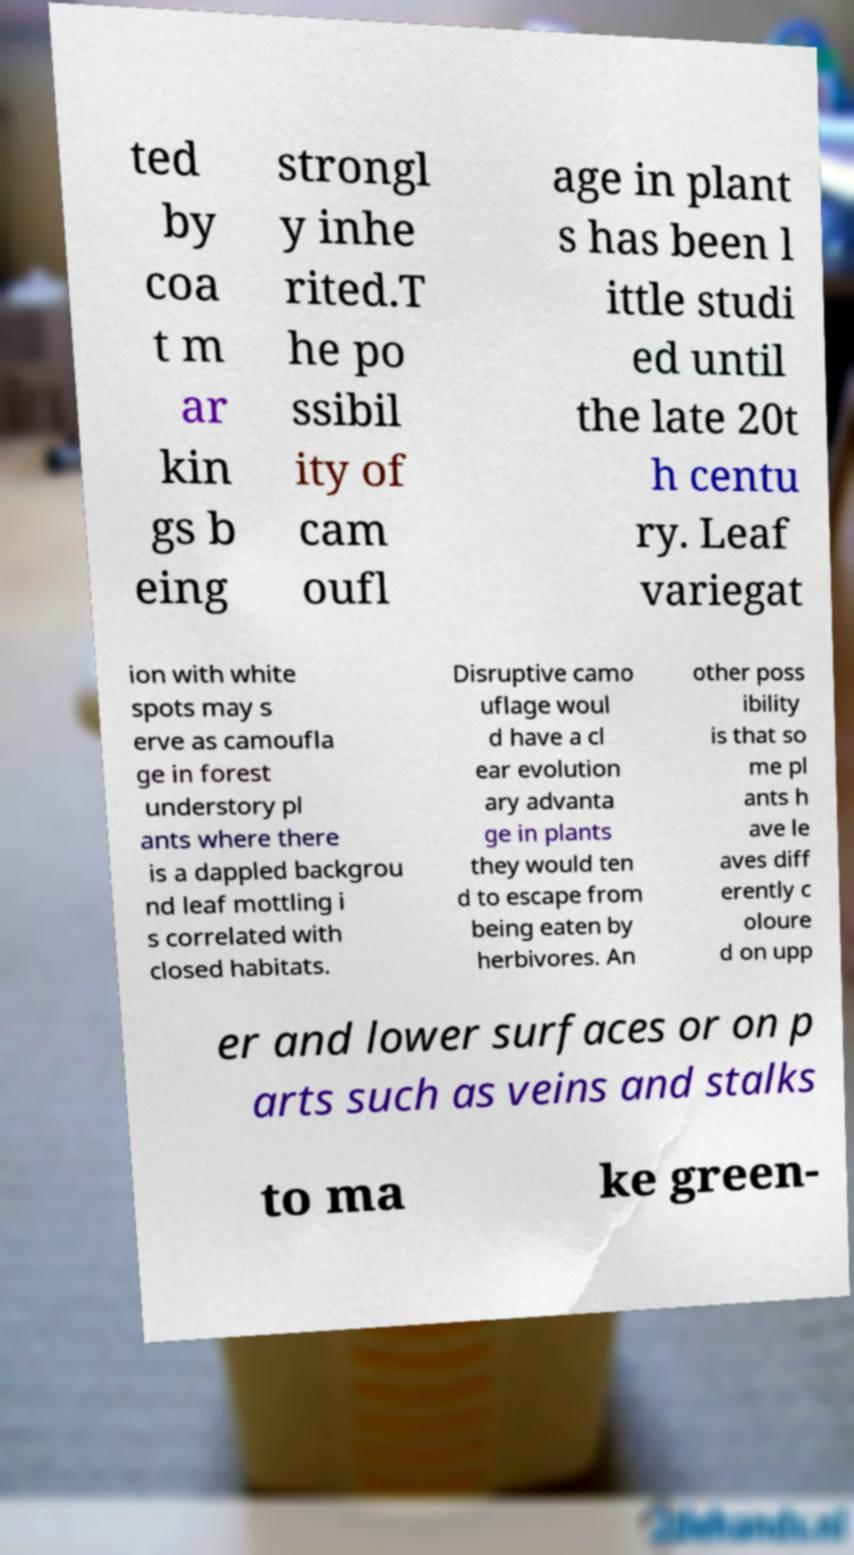What messages or text are displayed in this image? I need them in a readable, typed format. ted by coa t m ar kin gs b eing strongl y inhe rited.T he po ssibil ity of cam oufl age in plant s has been l ittle studi ed until the late 20t h centu ry. Leaf variegat ion with white spots may s erve as camoufla ge in forest understory pl ants where there is a dappled backgrou nd leaf mottling i s correlated with closed habitats. Disruptive camo uflage woul d have a cl ear evolution ary advanta ge in plants they would ten d to escape from being eaten by herbivores. An other poss ibility is that so me pl ants h ave le aves diff erently c oloure d on upp er and lower surfaces or on p arts such as veins and stalks to ma ke green- 